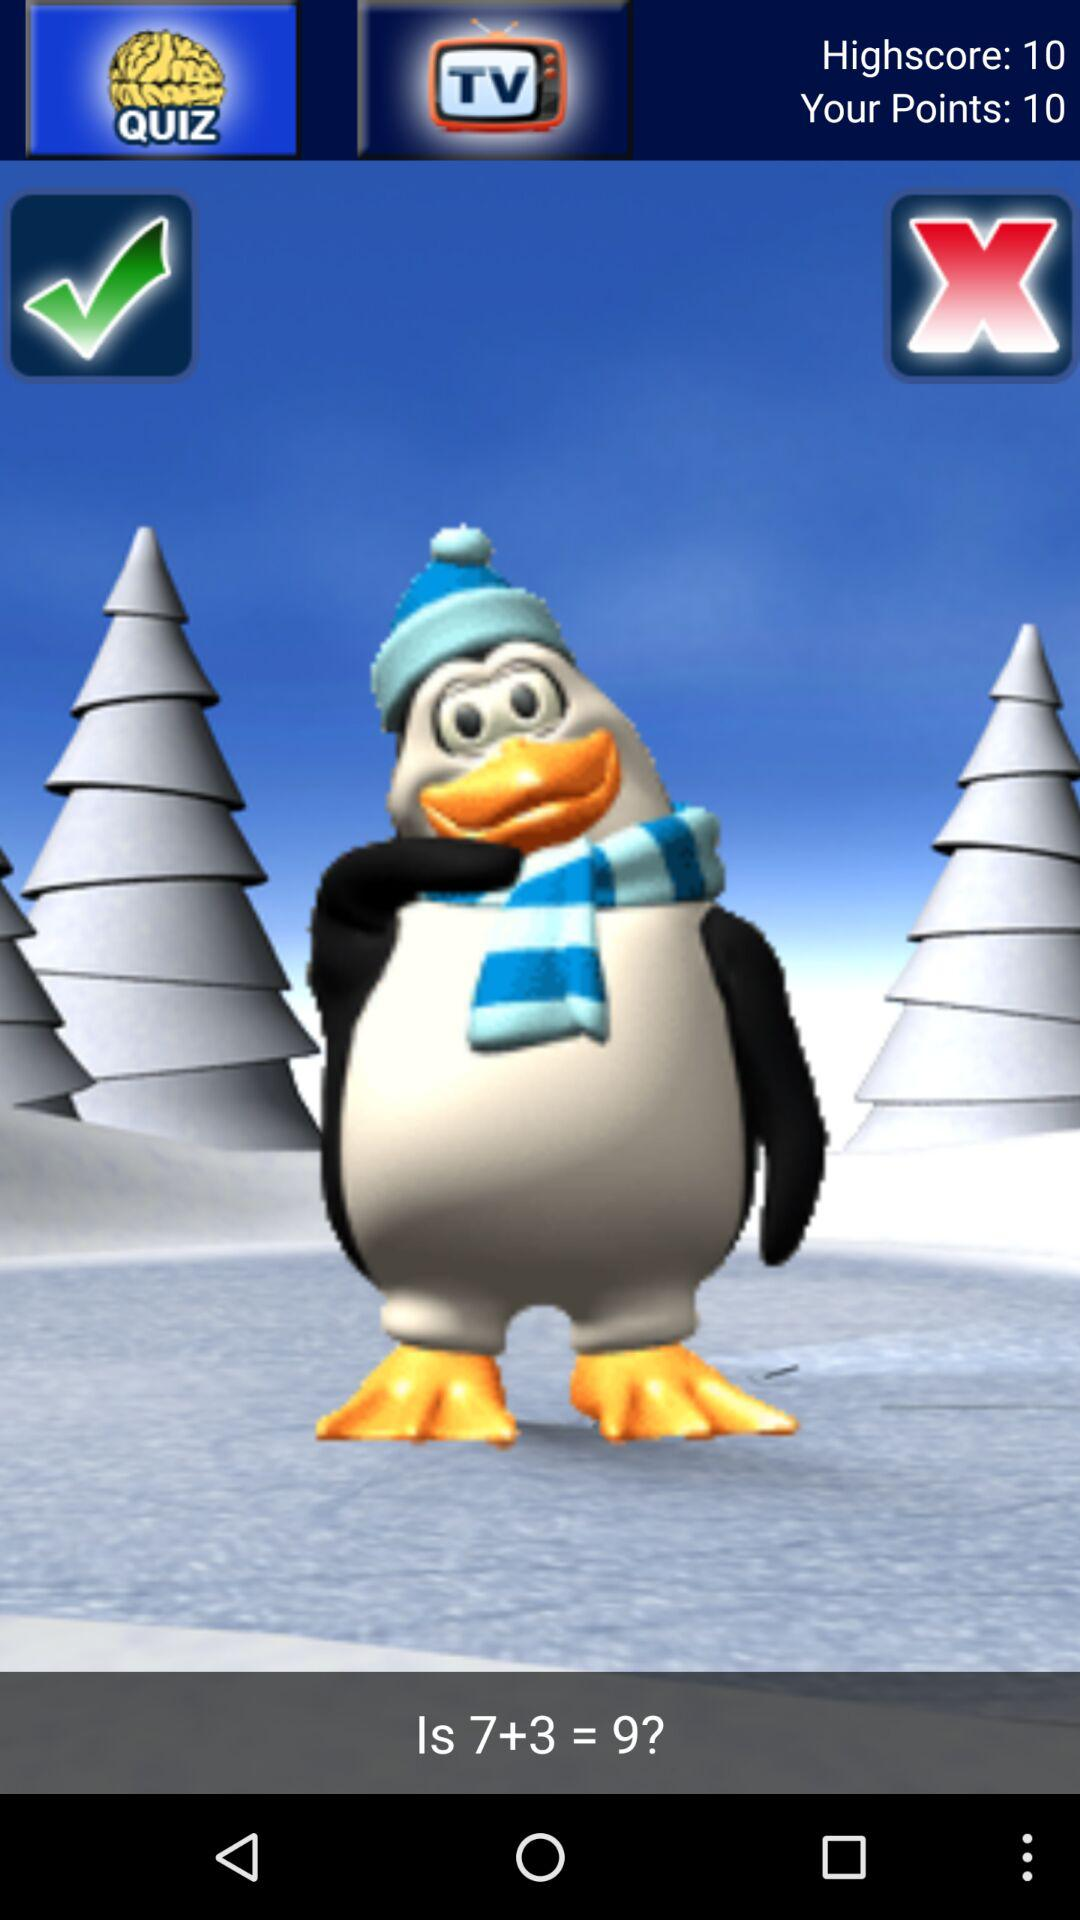What is the high score? The high score is 10 points. 